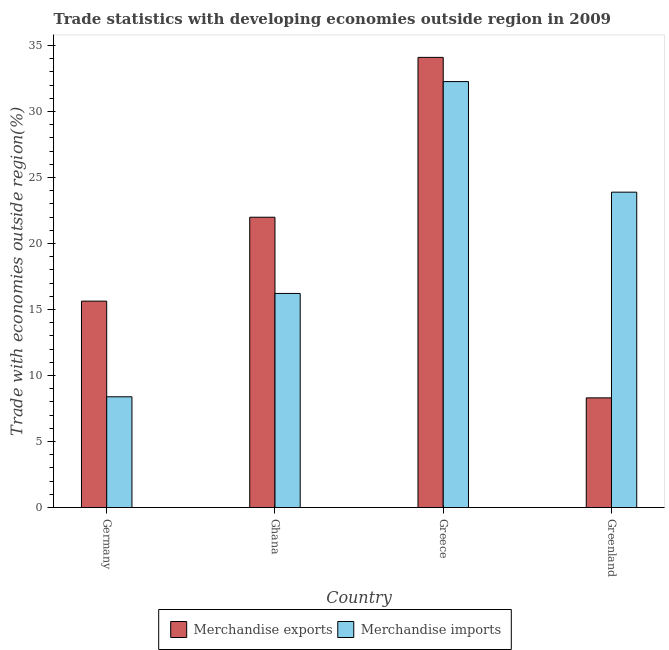How many different coloured bars are there?
Make the answer very short. 2. How many groups of bars are there?
Keep it short and to the point. 4. How many bars are there on the 2nd tick from the left?
Keep it short and to the point. 2. What is the label of the 4th group of bars from the left?
Make the answer very short. Greenland. What is the merchandise imports in Germany?
Keep it short and to the point. 8.39. Across all countries, what is the maximum merchandise exports?
Keep it short and to the point. 34.1. Across all countries, what is the minimum merchandise exports?
Your answer should be compact. 8.31. In which country was the merchandise exports maximum?
Ensure brevity in your answer.  Greece. In which country was the merchandise exports minimum?
Your answer should be compact. Greenland. What is the total merchandise exports in the graph?
Your answer should be very brief. 80.03. What is the difference between the merchandise exports in Germany and that in Greece?
Provide a succinct answer. -18.46. What is the difference between the merchandise exports in Greenland and the merchandise imports in Greece?
Provide a succinct answer. -23.96. What is the average merchandise imports per country?
Keep it short and to the point. 20.19. What is the difference between the merchandise imports and merchandise exports in Ghana?
Give a very brief answer. -5.77. In how many countries, is the merchandise imports greater than 4 %?
Give a very brief answer. 4. What is the ratio of the merchandise exports in Greece to that in Greenland?
Your answer should be compact. 4.1. Is the merchandise exports in Germany less than that in Greenland?
Ensure brevity in your answer.  No. Is the difference between the merchandise exports in Ghana and Greenland greater than the difference between the merchandise imports in Ghana and Greenland?
Your answer should be very brief. Yes. What is the difference between the highest and the second highest merchandise exports?
Keep it short and to the point. 12.11. What is the difference between the highest and the lowest merchandise imports?
Your answer should be compact. 23.88. In how many countries, is the merchandise exports greater than the average merchandise exports taken over all countries?
Keep it short and to the point. 2. What does the 2nd bar from the left in Greenland represents?
Give a very brief answer. Merchandise imports. What does the 1st bar from the right in Germany represents?
Provide a short and direct response. Merchandise imports. Are all the bars in the graph horizontal?
Offer a very short reply. No. How many countries are there in the graph?
Your answer should be compact. 4. What is the difference between two consecutive major ticks on the Y-axis?
Provide a succinct answer. 5. Are the values on the major ticks of Y-axis written in scientific E-notation?
Your answer should be compact. No. How many legend labels are there?
Offer a very short reply. 2. What is the title of the graph?
Offer a terse response. Trade statistics with developing economies outside region in 2009. Does "Old" appear as one of the legend labels in the graph?
Offer a terse response. No. What is the label or title of the X-axis?
Provide a short and direct response. Country. What is the label or title of the Y-axis?
Make the answer very short. Trade with economies outside region(%). What is the Trade with economies outside region(%) of Merchandise exports in Germany?
Keep it short and to the point. 15.63. What is the Trade with economies outside region(%) in Merchandise imports in Germany?
Your response must be concise. 8.39. What is the Trade with economies outside region(%) of Merchandise exports in Ghana?
Your answer should be very brief. 21.99. What is the Trade with economies outside region(%) in Merchandise imports in Ghana?
Your answer should be very brief. 16.22. What is the Trade with economies outside region(%) in Merchandise exports in Greece?
Offer a terse response. 34.1. What is the Trade with economies outside region(%) of Merchandise imports in Greece?
Provide a succinct answer. 32.26. What is the Trade with economies outside region(%) in Merchandise exports in Greenland?
Offer a terse response. 8.31. What is the Trade with economies outside region(%) of Merchandise imports in Greenland?
Provide a succinct answer. 23.89. Across all countries, what is the maximum Trade with economies outside region(%) of Merchandise exports?
Offer a terse response. 34.1. Across all countries, what is the maximum Trade with economies outside region(%) in Merchandise imports?
Your answer should be very brief. 32.26. Across all countries, what is the minimum Trade with economies outside region(%) in Merchandise exports?
Your response must be concise. 8.31. Across all countries, what is the minimum Trade with economies outside region(%) in Merchandise imports?
Provide a succinct answer. 8.39. What is the total Trade with economies outside region(%) of Merchandise exports in the graph?
Make the answer very short. 80.03. What is the total Trade with economies outside region(%) of Merchandise imports in the graph?
Your response must be concise. 80.76. What is the difference between the Trade with economies outside region(%) of Merchandise exports in Germany and that in Ghana?
Provide a succinct answer. -6.36. What is the difference between the Trade with economies outside region(%) of Merchandise imports in Germany and that in Ghana?
Provide a short and direct response. -7.83. What is the difference between the Trade with economies outside region(%) of Merchandise exports in Germany and that in Greece?
Provide a succinct answer. -18.46. What is the difference between the Trade with economies outside region(%) of Merchandise imports in Germany and that in Greece?
Offer a very short reply. -23.88. What is the difference between the Trade with economies outside region(%) of Merchandise exports in Germany and that in Greenland?
Your answer should be compact. 7.33. What is the difference between the Trade with economies outside region(%) in Merchandise imports in Germany and that in Greenland?
Ensure brevity in your answer.  -15.5. What is the difference between the Trade with economies outside region(%) of Merchandise exports in Ghana and that in Greece?
Give a very brief answer. -12.11. What is the difference between the Trade with economies outside region(%) in Merchandise imports in Ghana and that in Greece?
Offer a very short reply. -16.05. What is the difference between the Trade with economies outside region(%) of Merchandise exports in Ghana and that in Greenland?
Provide a short and direct response. 13.68. What is the difference between the Trade with economies outside region(%) in Merchandise imports in Ghana and that in Greenland?
Keep it short and to the point. -7.67. What is the difference between the Trade with economies outside region(%) in Merchandise exports in Greece and that in Greenland?
Provide a short and direct response. 25.79. What is the difference between the Trade with economies outside region(%) of Merchandise imports in Greece and that in Greenland?
Ensure brevity in your answer.  8.38. What is the difference between the Trade with economies outside region(%) in Merchandise exports in Germany and the Trade with economies outside region(%) in Merchandise imports in Ghana?
Ensure brevity in your answer.  -0.58. What is the difference between the Trade with economies outside region(%) in Merchandise exports in Germany and the Trade with economies outside region(%) in Merchandise imports in Greece?
Make the answer very short. -16.63. What is the difference between the Trade with economies outside region(%) of Merchandise exports in Germany and the Trade with economies outside region(%) of Merchandise imports in Greenland?
Provide a succinct answer. -8.25. What is the difference between the Trade with economies outside region(%) of Merchandise exports in Ghana and the Trade with economies outside region(%) of Merchandise imports in Greece?
Your answer should be very brief. -10.27. What is the difference between the Trade with economies outside region(%) in Merchandise exports in Ghana and the Trade with economies outside region(%) in Merchandise imports in Greenland?
Ensure brevity in your answer.  -1.9. What is the difference between the Trade with economies outside region(%) in Merchandise exports in Greece and the Trade with economies outside region(%) in Merchandise imports in Greenland?
Keep it short and to the point. 10.21. What is the average Trade with economies outside region(%) in Merchandise exports per country?
Offer a terse response. 20.01. What is the average Trade with economies outside region(%) in Merchandise imports per country?
Make the answer very short. 20.19. What is the difference between the Trade with economies outside region(%) in Merchandise exports and Trade with economies outside region(%) in Merchandise imports in Germany?
Keep it short and to the point. 7.25. What is the difference between the Trade with economies outside region(%) of Merchandise exports and Trade with economies outside region(%) of Merchandise imports in Ghana?
Offer a very short reply. 5.77. What is the difference between the Trade with economies outside region(%) of Merchandise exports and Trade with economies outside region(%) of Merchandise imports in Greece?
Ensure brevity in your answer.  1.83. What is the difference between the Trade with economies outside region(%) in Merchandise exports and Trade with economies outside region(%) in Merchandise imports in Greenland?
Make the answer very short. -15.58. What is the ratio of the Trade with economies outside region(%) of Merchandise exports in Germany to that in Ghana?
Give a very brief answer. 0.71. What is the ratio of the Trade with economies outside region(%) in Merchandise imports in Germany to that in Ghana?
Give a very brief answer. 0.52. What is the ratio of the Trade with economies outside region(%) of Merchandise exports in Germany to that in Greece?
Your response must be concise. 0.46. What is the ratio of the Trade with economies outside region(%) of Merchandise imports in Germany to that in Greece?
Keep it short and to the point. 0.26. What is the ratio of the Trade with economies outside region(%) of Merchandise exports in Germany to that in Greenland?
Make the answer very short. 1.88. What is the ratio of the Trade with economies outside region(%) in Merchandise imports in Germany to that in Greenland?
Ensure brevity in your answer.  0.35. What is the ratio of the Trade with economies outside region(%) of Merchandise exports in Ghana to that in Greece?
Provide a succinct answer. 0.64. What is the ratio of the Trade with economies outside region(%) of Merchandise imports in Ghana to that in Greece?
Offer a terse response. 0.5. What is the ratio of the Trade with economies outside region(%) in Merchandise exports in Ghana to that in Greenland?
Your response must be concise. 2.65. What is the ratio of the Trade with economies outside region(%) of Merchandise imports in Ghana to that in Greenland?
Keep it short and to the point. 0.68. What is the ratio of the Trade with economies outside region(%) of Merchandise exports in Greece to that in Greenland?
Your answer should be very brief. 4.1. What is the ratio of the Trade with economies outside region(%) in Merchandise imports in Greece to that in Greenland?
Offer a terse response. 1.35. What is the difference between the highest and the second highest Trade with economies outside region(%) of Merchandise exports?
Provide a succinct answer. 12.11. What is the difference between the highest and the second highest Trade with economies outside region(%) of Merchandise imports?
Ensure brevity in your answer.  8.38. What is the difference between the highest and the lowest Trade with economies outside region(%) in Merchandise exports?
Give a very brief answer. 25.79. What is the difference between the highest and the lowest Trade with economies outside region(%) of Merchandise imports?
Make the answer very short. 23.88. 